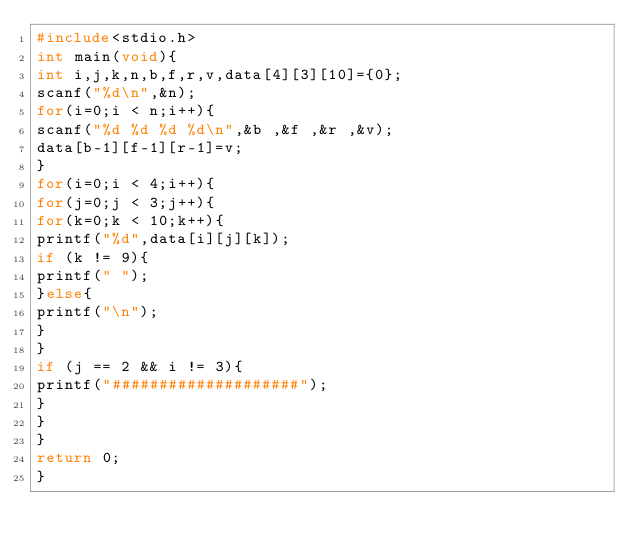Convert code to text. <code><loc_0><loc_0><loc_500><loc_500><_C_>#include<stdio.h>
int main(void){
int i,j,k,n,b,f,r,v,data[4][3][10]={0};
scanf("%d\n",&n);
for(i=0;i < n;i++){
scanf("%d %d %d %d\n",&b ,&f ,&r ,&v);
data[b-1][f-1][r-1]=v;
}
for(i=0;i < 4;i++){
for(j=0;j < 3;j++){
for(k=0;k < 10;k++){
printf("%d",data[i][j][k]);
if (k != 9){
printf(" ");
}else{
printf("\n");
}
}
if (j == 2 && i != 3){
printf("####################");
}
}
}
return 0;
}</code> 